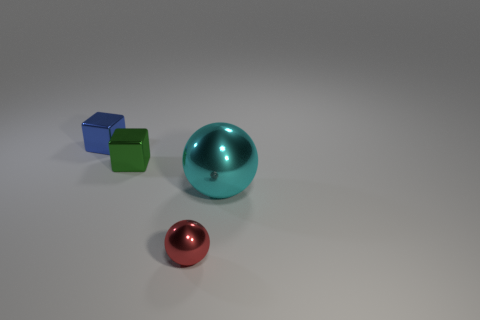Add 3 big cyan balls. How many objects exist? 7 Subtract all green spheres. Subtract all blue objects. How many objects are left? 3 Add 1 blue cubes. How many blue cubes are left? 2 Add 4 big purple spheres. How many big purple spheres exist? 4 Subtract 0 cyan cylinders. How many objects are left? 4 